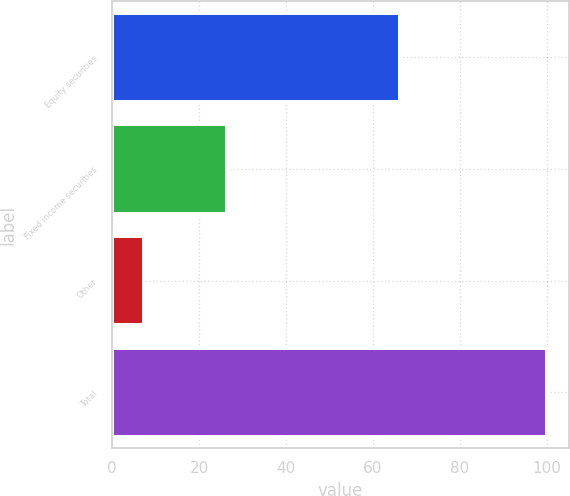Convert chart. <chart><loc_0><loc_0><loc_500><loc_500><bar_chart><fcel>Equity securities<fcel>Fixed income securities<fcel>Other<fcel>Total<nl><fcel>66.2<fcel>26.4<fcel>7.4<fcel>100<nl></chart> 